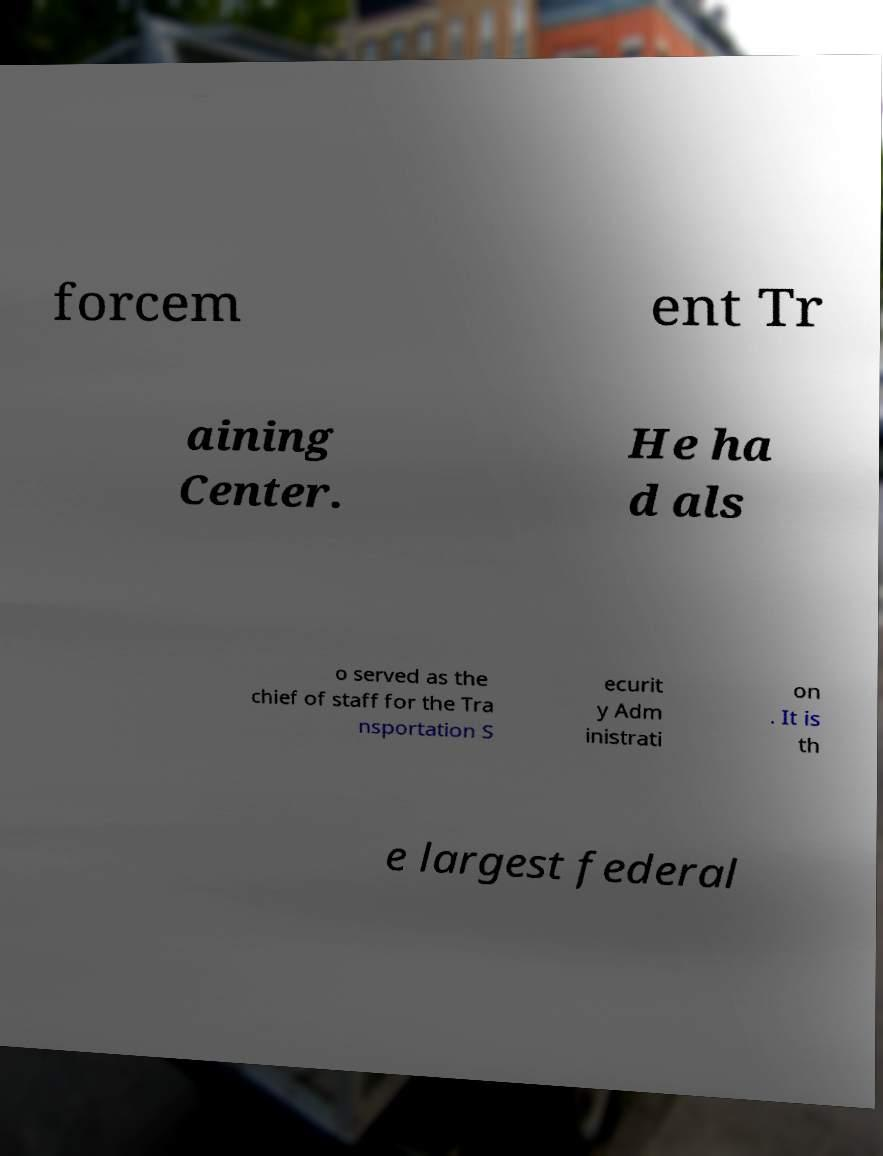Can you read and provide the text displayed in the image?This photo seems to have some interesting text. Can you extract and type it out for me? forcem ent Tr aining Center. He ha d als o served as the chief of staff for the Tra nsportation S ecurit y Adm inistrati on . It is th e largest federal 